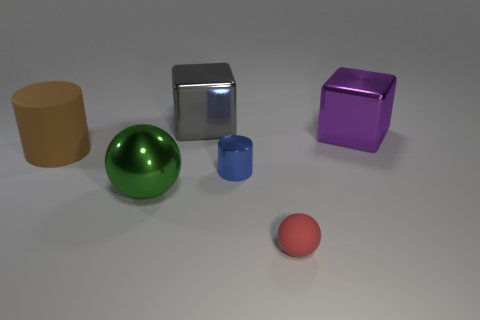Add 4 big brown matte things. How many objects exist? 10 Add 3 large shiny spheres. How many large shiny spheres are left? 4 Add 1 blue objects. How many blue objects exist? 2 Subtract 0 gray balls. How many objects are left? 6 Subtract all blue matte blocks. Subtract all red balls. How many objects are left? 5 